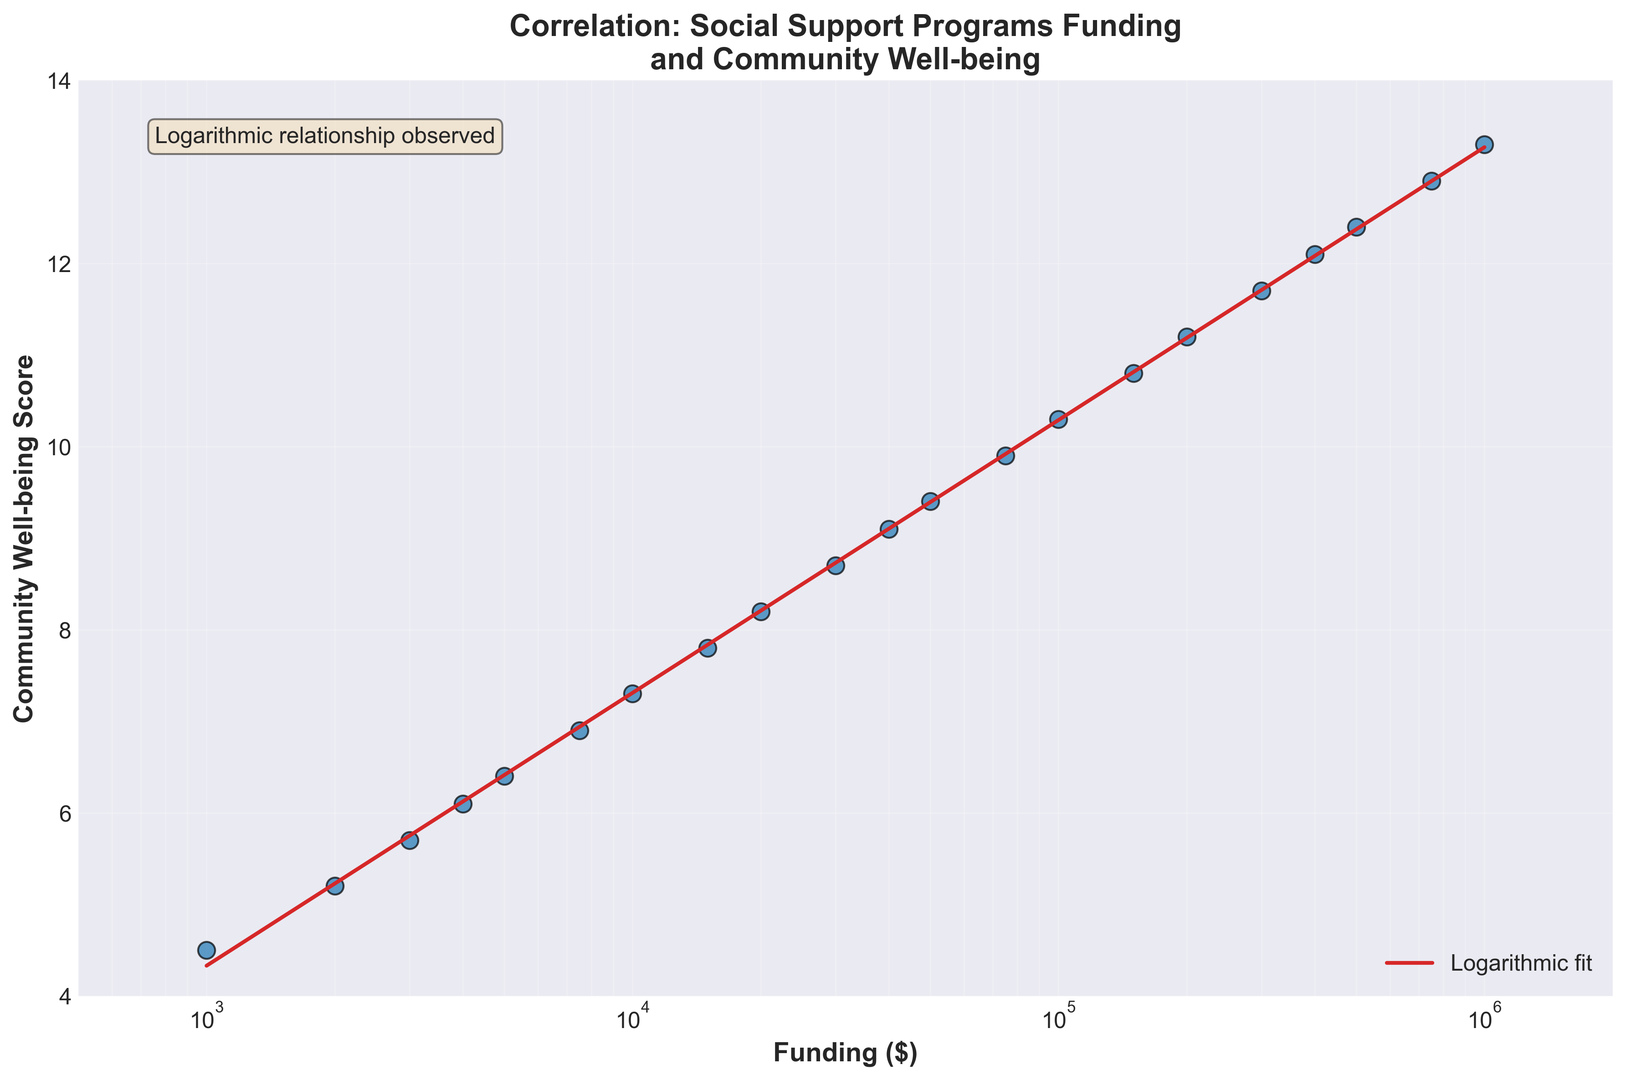What type of relationship is observed between funding and community well-being in the plot? The plot shows a logarithmic fit, which suggests a logarithmic relationship. The curve fits the data points well, indicating that as funding increases, community well-being improves in a logarithmic manner.
Answer: Logarithmic How does community well-being change as funding moves from $1,000 to $100,000? From the graph, we observe that community well-being scores increase more rapidly at lower funding levels and start to plateau as funding increases. Specifically, well-being moves from around 4.5 to approximately 10.3.
Answer: It increases from 4.5 to 10.3 What is the community well-being score when the funding is $20,000? By looking at the data points on the plot, at $20,000 funding, the corresponding community well-being score is 8.2.
Answer: 8.2 Between which two consecutive funding levels does the greatest increase in community well-being occur? By examining the steepness of points, the greatest increase in community well-being occurs between $200,000 and $300,000 as the slope is steepest there.
Answer: $200,000 and $300,000 How does the fit line behave as funding increases to very high levels, e.g., $1,000,000? The log fit line shows that the rate of increase in community well-being slows down significantly as we move to higher funding levels, indicating a logarithmic growth model.
Answer: Slows down What is the community well-being score when the logarithmic fit line approximates it for a funding of $400,000? According to the log fit line on the plot, when funding is $400,000, community well-being approximates around 12.1.
Answer: 12.1 Does the plot display any outliers or anomalies in the data set? By inspecting the plot, there don’t appear to be any noticeable outliers or anomalies, as all data points follow the logarithmic trend closely.
Answer: No On average, how much does the well-being score increase when funding doubles, for example from $10,000 to $20,000? By comparing logarithmic increments, each doubling of funding results in an increase of about 0.9 in community well-being score on average. From $10,000 to $20,000, the increase is around 0.9.
Answer: 0.9 In the plot, which color is used to represent the logarithmic fit line? The logarithmic fit line is represented using the color red, while the data points are shown in blue with black edges.
Answer: Red Between $50,000 and $400,000, how much does the community well-being score improve? At $50,000, the score is approximately 9.4, and at $400,000, it is about 12.1. The improvement is thus calculated as 12.1 - 9.4.
Answer: 2.7 